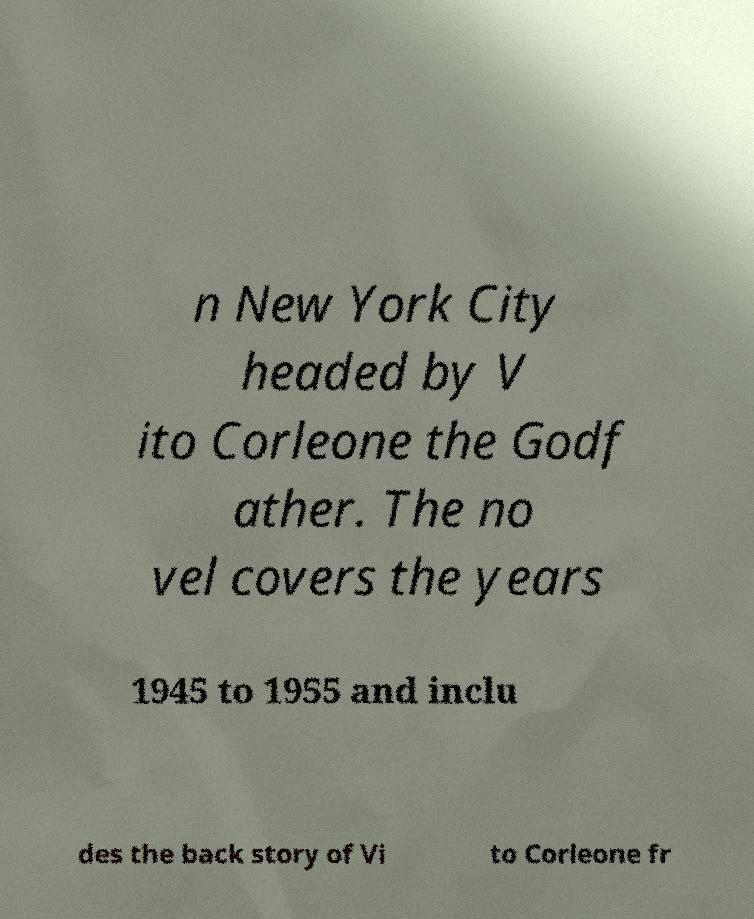For documentation purposes, I need the text within this image transcribed. Could you provide that? n New York City headed by V ito Corleone the Godf ather. The no vel covers the years 1945 to 1955 and inclu des the back story of Vi to Corleone fr 